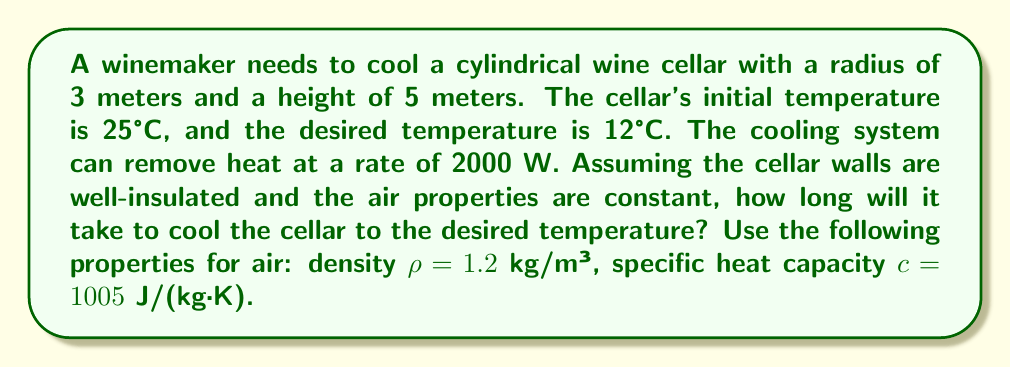Help me with this question. Let's approach this problem step-by-step:

1) First, we need to calculate the volume of the cellar:
   $$V = \pi r^2 h = \pi \cdot 3^2 \cdot 5 = 45\pi \approx 141.37 \text{ m}^3$$

2) Next, we calculate the mass of air in the cellar:
   $$m = \rho V = 1.2 \cdot 141.37 = 169.64 \text{ kg}$$

3) Now, we need to determine the amount of heat that needs to be removed:
   $$Q = mc\Delta T = 169.64 \cdot 1005 \cdot (25 - 12) = 2,217,594.6 \text{ J}$$

4) Given that the cooling system can remove heat at a rate of 2000 W, we can calculate the time needed:
   $$t = \frac{Q}{P} = \frac{2,217,594.6}{2000} = 1108.8 \text{ seconds}$$

5) Converting to minutes:
   $$t = \frac{1108.8}{60} \approx 18.48 \text{ minutes}$$

Therefore, it will take approximately 18.5 minutes to cool the cellar to the desired temperature.
Answer: 18.5 minutes 